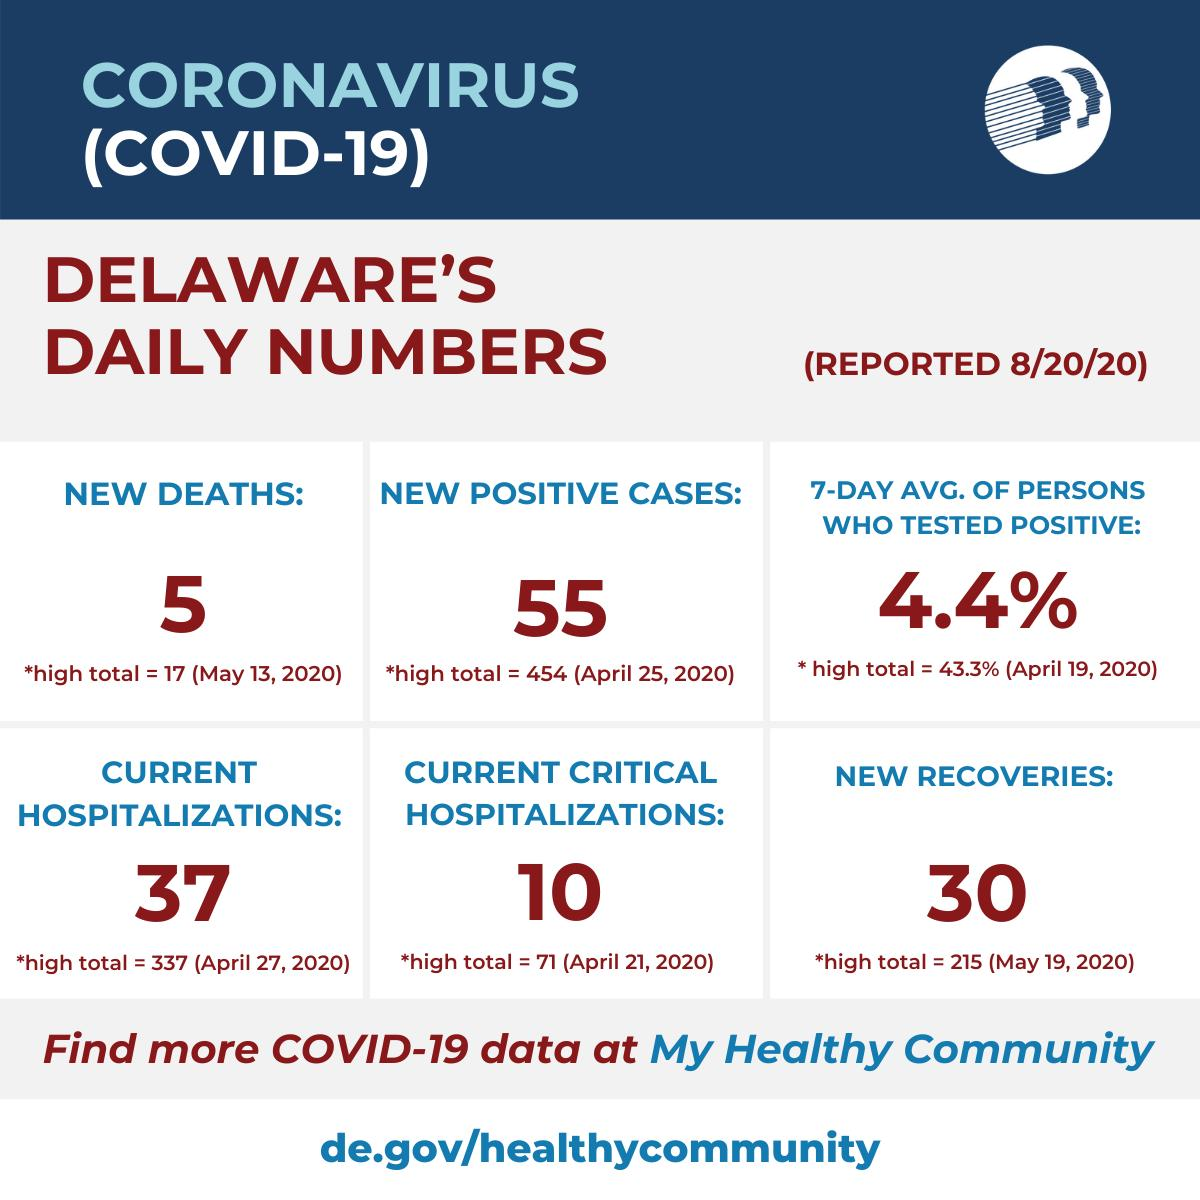Indicate a few pertinent items in this graphic. The highest number of recoveries reported in Delaware was on May 19, 2020. On August 20, it was reported that the average number of people who tested positive for a particular condition over the course of the previous 7 days was 4.4%. On April 21, 2020, the highest number of critical hospitalizations was reported in Delaware. On May 13, 2020, the highest number of deaths was reported in the state of Delaware. On April 27, 2020, the highest number of hospitalizations was reported in Delaware. 